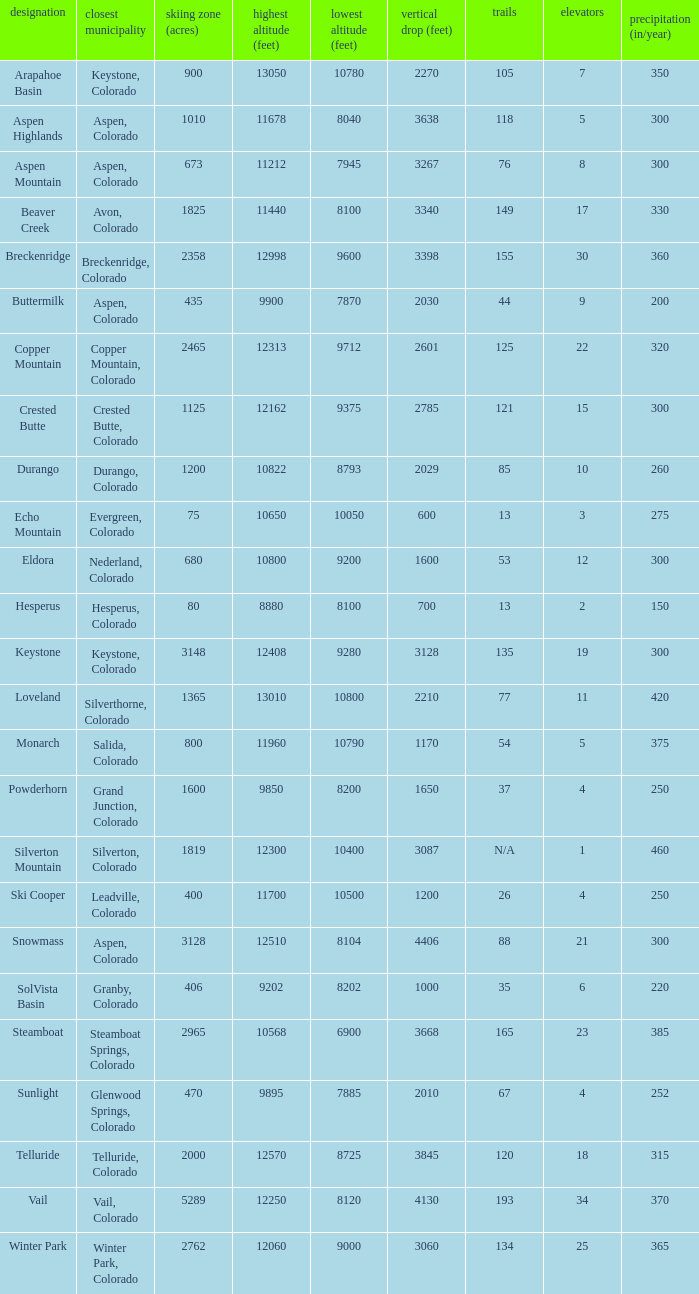What is the snowfall for ski resort Snowmass? 300.0. 